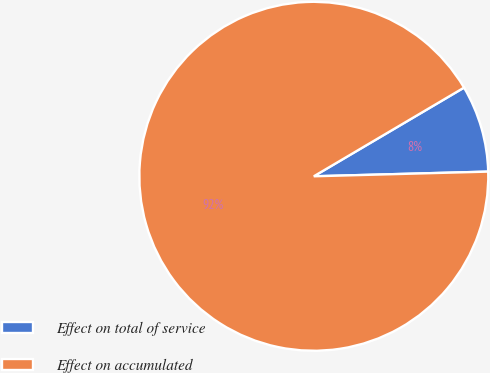Convert chart to OTSL. <chart><loc_0><loc_0><loc_500><loc_500><pie_chart><fcel>Effect on total of service<fcel>Effect on accumulated<nl><fcel>8.06%<fcel>91.94%<nl></chart> 